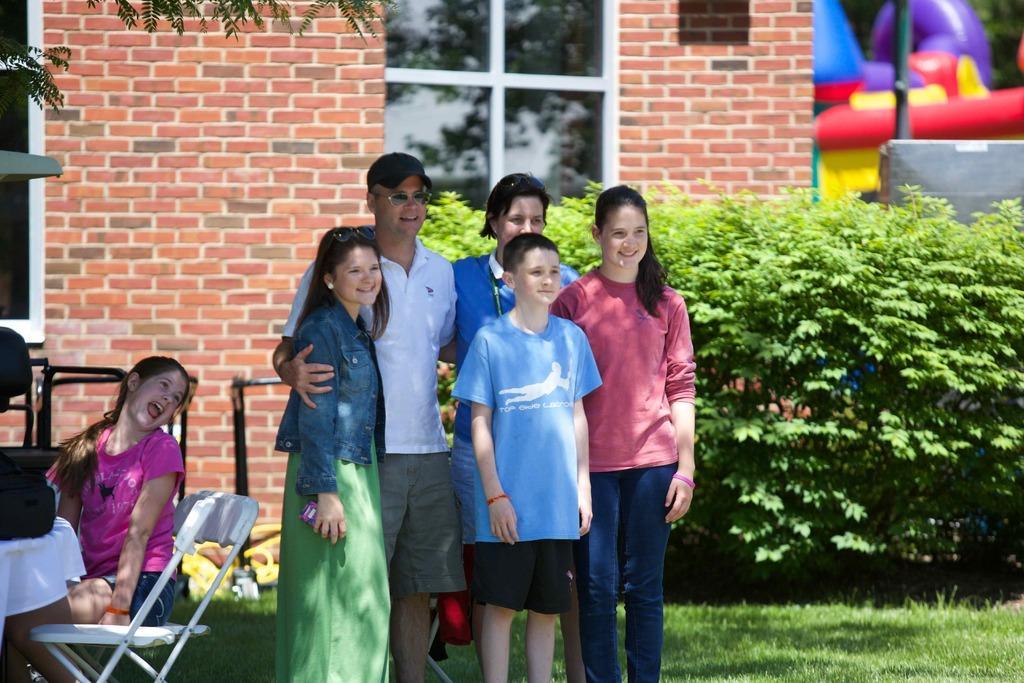Describe this image in one or two sentences. In this image I can see there are five persons visible in front of bushes and I can see the wall and window and back side of bushes and pole and inflatable visible on the right side and I can see a girl sitting on chair in front of her I can see a table with white color cloth. 